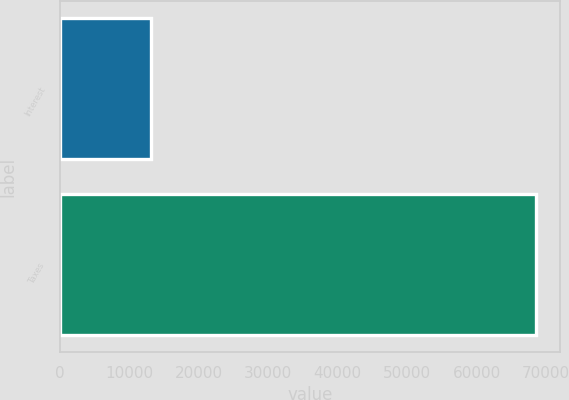Convert chart to OTSL. <chart><loc_0><loc_0><loc_500><loc_500><bar_chart><fcel>Interest<fcel>Taxes<nl><fcel>13039<fcel>68534<nl></chart> 